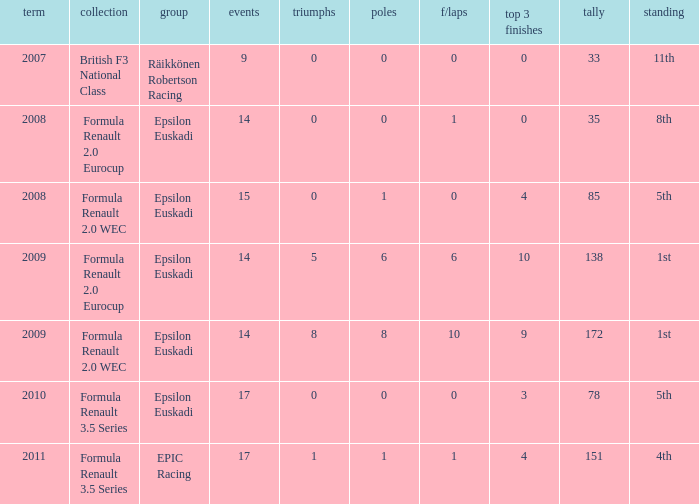What team was he on when he finished in 11th position? Räikkönen Robertson Racing. 